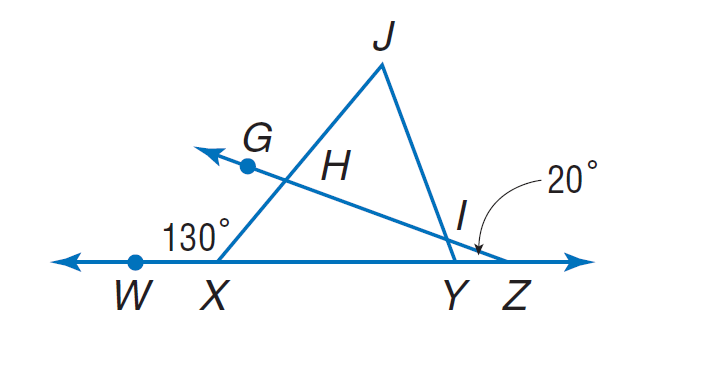Answer the mathemtical geometry problem and directly provide the correct option letter.
Question: If \frac { I J } { X J } = \frac { H J } { Y J }, m \angle W X J = 130, and m \angle W Z G = 20, find m \angle J I H.
Choices: A: 25 B: 30 C: 40 D: 50 D 